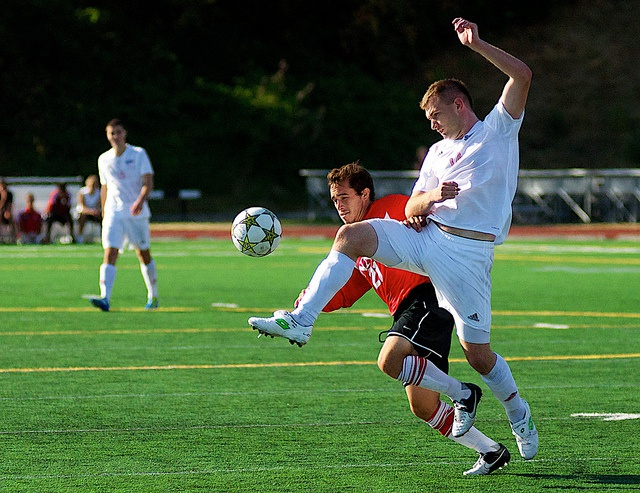Describe the objects in this image and their specific colors. I can see people in black, darkgray, gray, and white tones, people in black, maroon, brown, and gray tones, people in black, white, gray, and darkgray tones, sports ball in black, darkgray, and white tones, and people in black, gray, and olive tones in this image. 